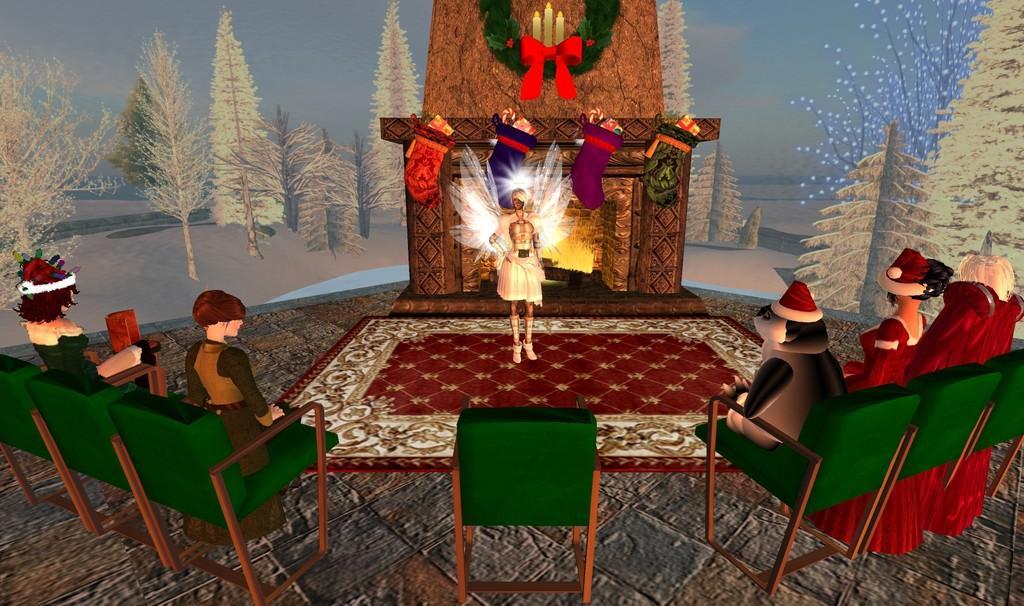Describe this image in one or two sentences. It is an animated picture. In this image, we can see few people and animal. Few are sitting on the chairs. At the bottom, we can see surface and mat. Background we can see so many trees, some objects and decorative things. Here a person is standing. 